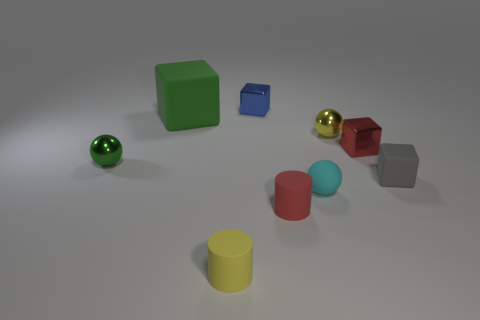What size is the metallic cube that is behind the big thing?
Your response must be concise. Small. Is there any other thing that has the same color as the big matte block?
Provide a succinct answer. Yes. Does the red thing that is on the right side of the yellow sphere have the same material as the small green object?
Your answer should be very brief. Yes. What number of matte objects are left of the yellow matte thing and on the right side of the small cyan matte sphere?
Provide a short and direct response. 0. There is a yellow object that is to the right of the tiny object behind the green block; what size is it?
Ensure brevity in your answer.  Small. Is there any other thing that is the same material as the cyan sphere?
Provide a succinct answer. Yes. Is the number of large matte objects greater than the number of purple rubber spheres?
Your answer should be compact. Yes. Does the small shiny thing to the left of the big green rubber thing have the same color as the tiny cylinder behind the yellow cylinder?
Provide a succinct answer. No. Is there a yellow shiny ball that is right of the rubber block that is on the right side of the small red metal object?
Give a very brief answer. No. Is the number of tiny gray matte objects behind the tiny yellow shiny thing less than the number of blue shiny objects left of the big green thing?
Keep it short and to the point. No. 